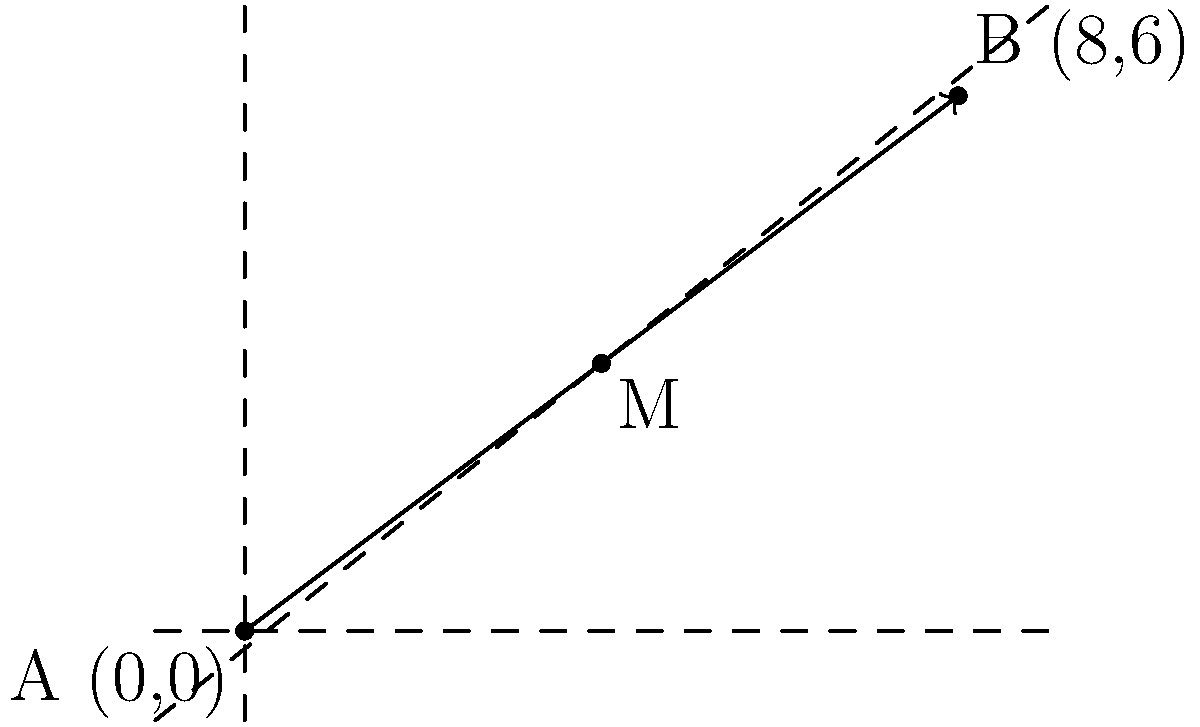During a practice session, you're analyzing a pass made between two players on the court. Player A is positioned at the origin (0,0), and Player B is at coordinates (8,6). To improve ball movement, you want to identify the optimal interception point for a defensive player. Calculate the coordinates of the midpoint of the pass, which represents the ideal position for the defender to intercept the ball. To find the midpoint of a line segment, we can use the midpoint formula:

$$ M_x = \frac{x_1 + x_2}{2}, \quad M_y = \frac{y_1 + y_2}{2} $$

Where $(x_1, y_1)$ are the coordinates of the first point and $(x_2, y_2)$ are the coordinates of the second point.

Given:
- Player A is at (0,0), so $x_1 = 0$ and $y_1 = 0$
- Player B is at (8,6), so $x_2 = 8$ and $y_2 = 6$

Step 1: Calculate the x-coordinate of the midpoint:
$$ M_x = \frac{x_1 + x_2}{2} = \frac{0 + 8}{2} = \frac{8}{2} = 4 $$

Step 2: Calculate the y-coordinate of the midpoint:
$$ M_y = \frac{y_1 + y_2}{2} = \frac{0 + 6}{2} = \frac{6}{2} = 3 $$

Therefore, the midpoint M has coordinates (4,3).
Answer: (4,3) 